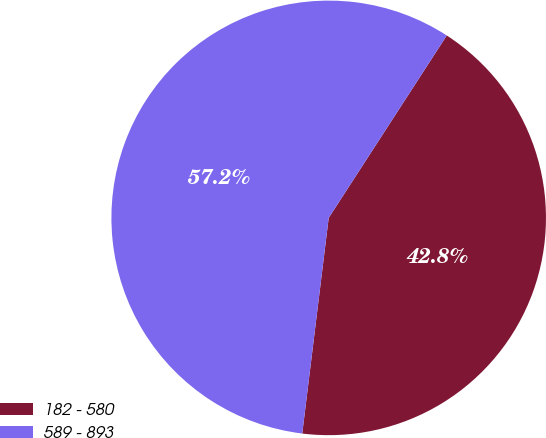Convert chart to OTSL. <chart><loc_0><loc_0><loc_500><loc_500><pie_chart><fcel>182 - 580<fcel>589 - 893<nl><fcel>42.8%<fcel>57.2%<nl></chart> 